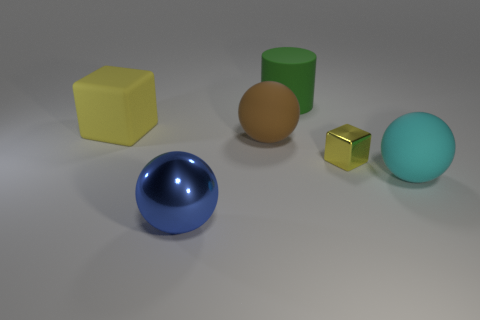There is a green cylinder that is the same material as the big cube; what is its size? The green cylinder appears to be of medium size relative to the other objects in the image, notably smaller than the large yellow cube and larger than the small golden cube. 